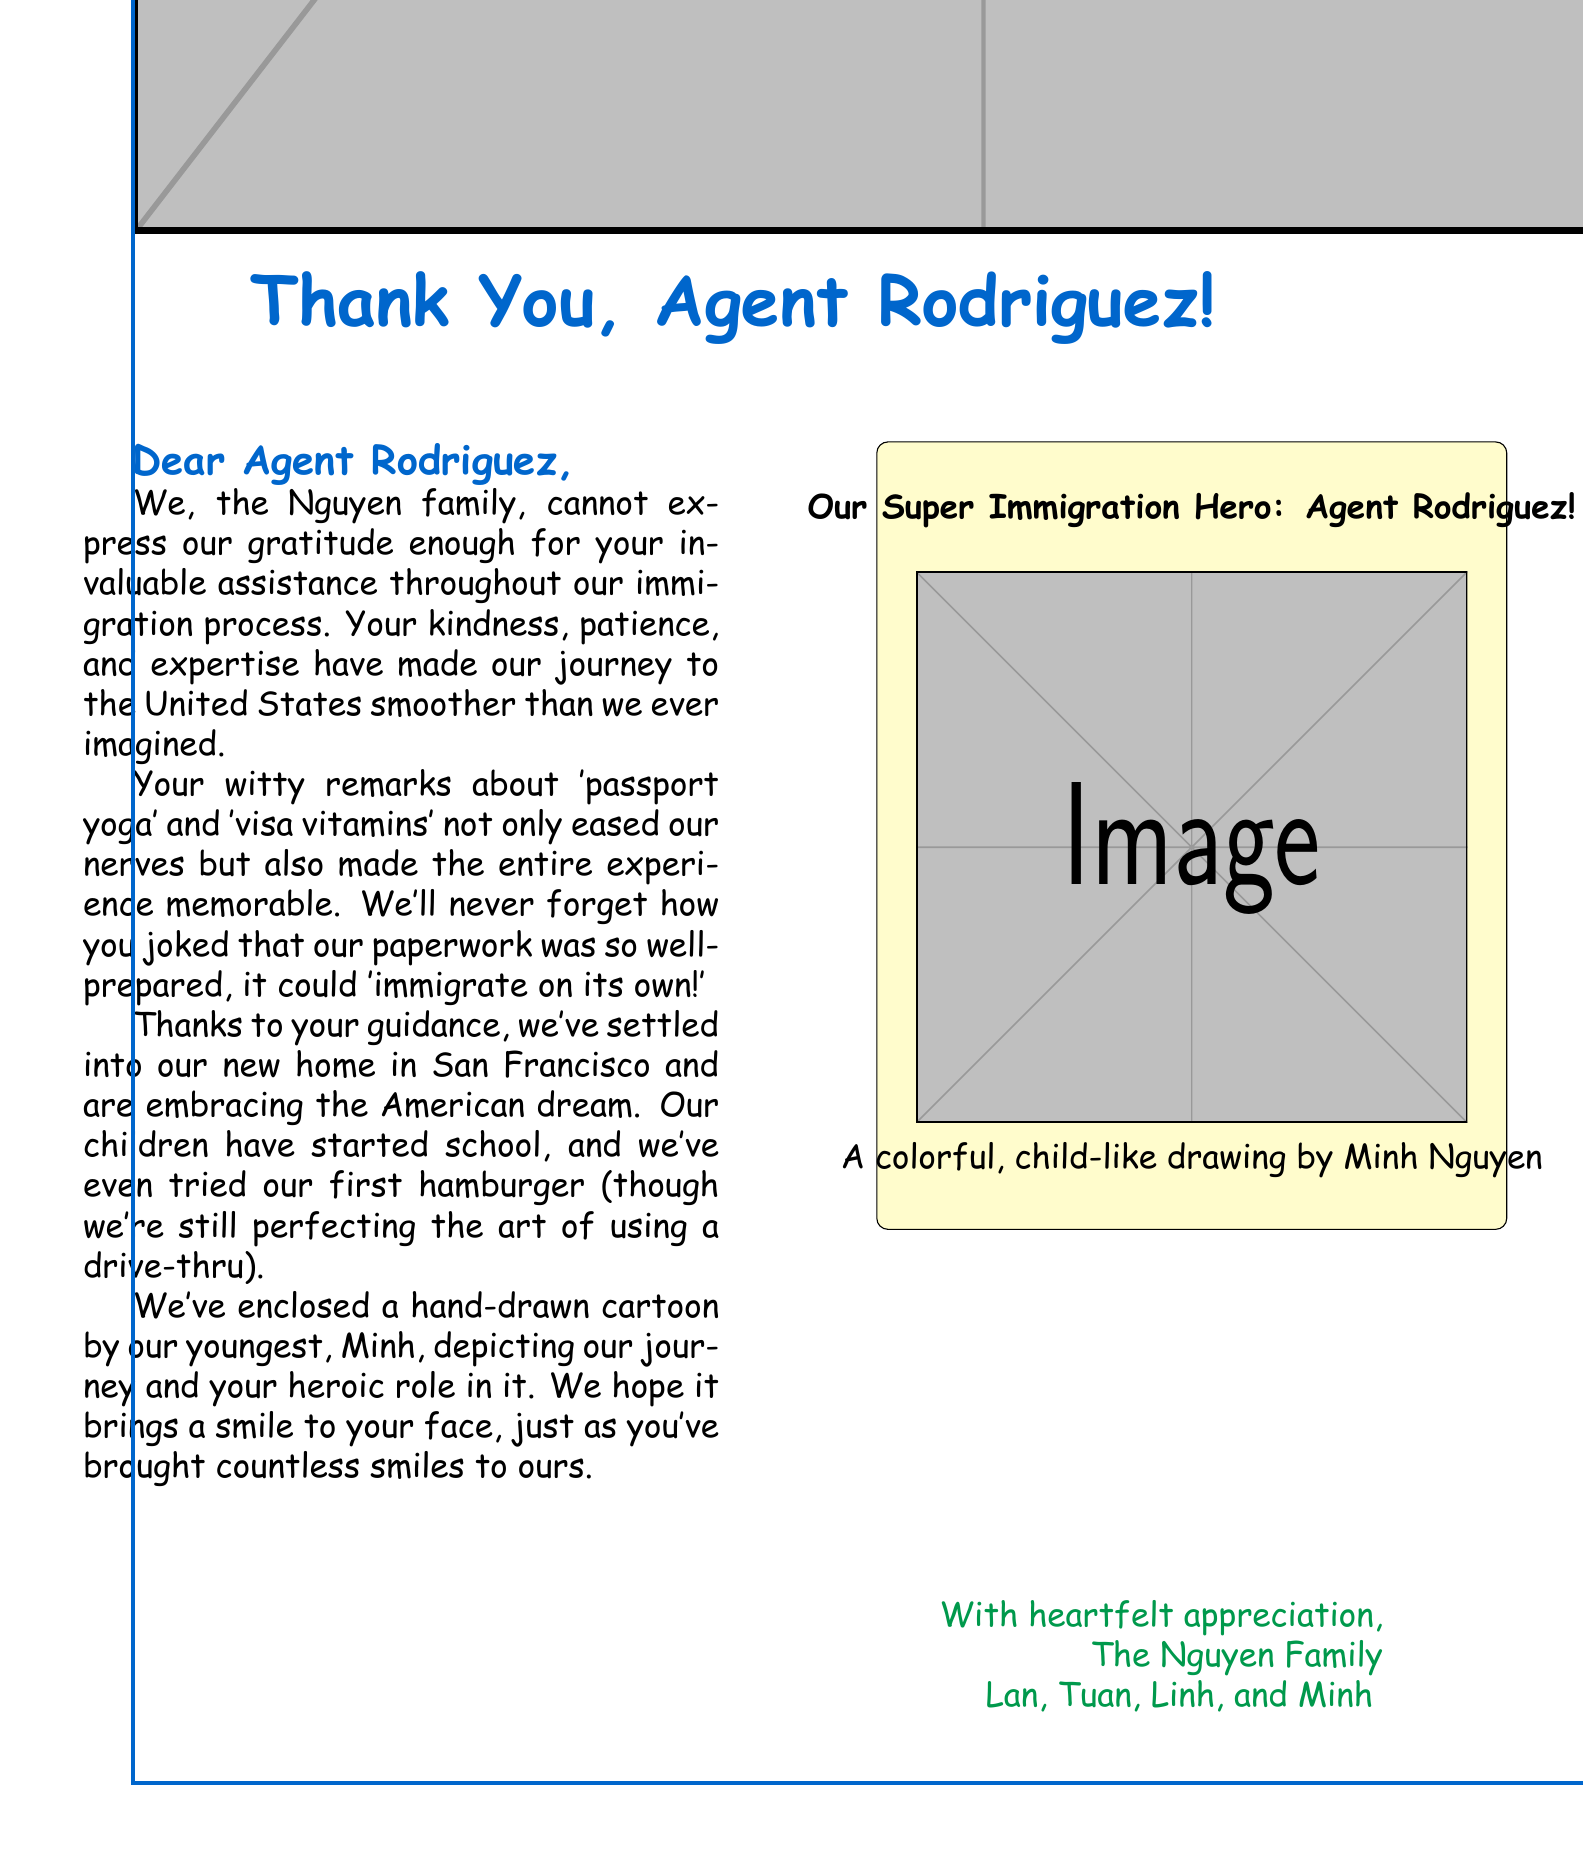What is the family name of the immigrants? The letter identifies the family as the Nguyen family.
Answer: Nguyen Who is the agent mentioned in the letter? The letter is addressed to Agent Rodriguez, who is helping the Nguyen family.
Answer: Agent Rodriguez When did the Nguyen family arrive in the United States? The letter states that the Nguyen family arrived on March 15, 2023.
Answer: March 15, 2023 What type of visa did the Nguyen family use? The letter mentions that they used an EB-3 Skilled Worker Visa.
Answer: EB-3 Skilled Worker Visa Which city is the Nguyen family’s new home? The letter states that they have settled in San Francisco.
Answer: San Francisco What humorous remark did Agent Rodriguez make about the paperwork? The agent joked that the paperwork was so well-prepared, it could 'immigrate on its own!'
Answer: it could 'immigrate on its own!' How many children are in the Nguyen family? The letter outlines that there are two children in the Nguyen family.
Answer: Two What is depicted in the enclosed cartoon? The cartoon shows scenes from their journey and Agent Rodriguez's role in it.
Answer: Their journey and Agent Rodriguez's role 